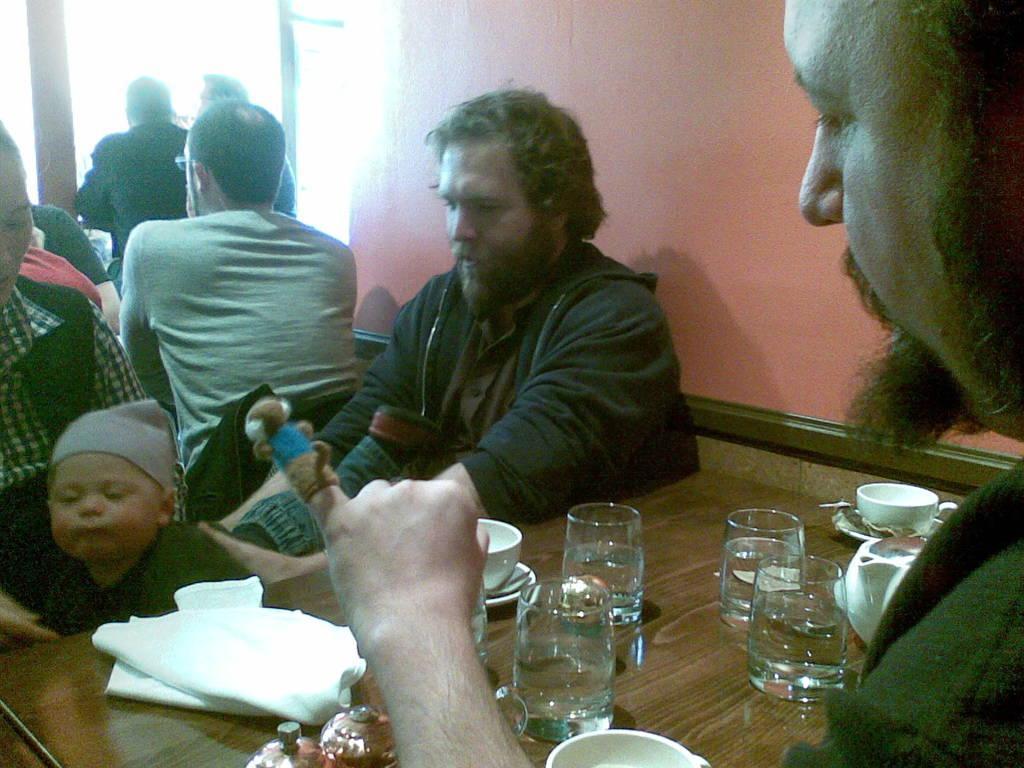Can you describe this image briefly? In this picture we can see a group of people sitting and in front of them there is table and on table we can see glasses, cup, saucer, tissue papers and in background we can see wall, window. 